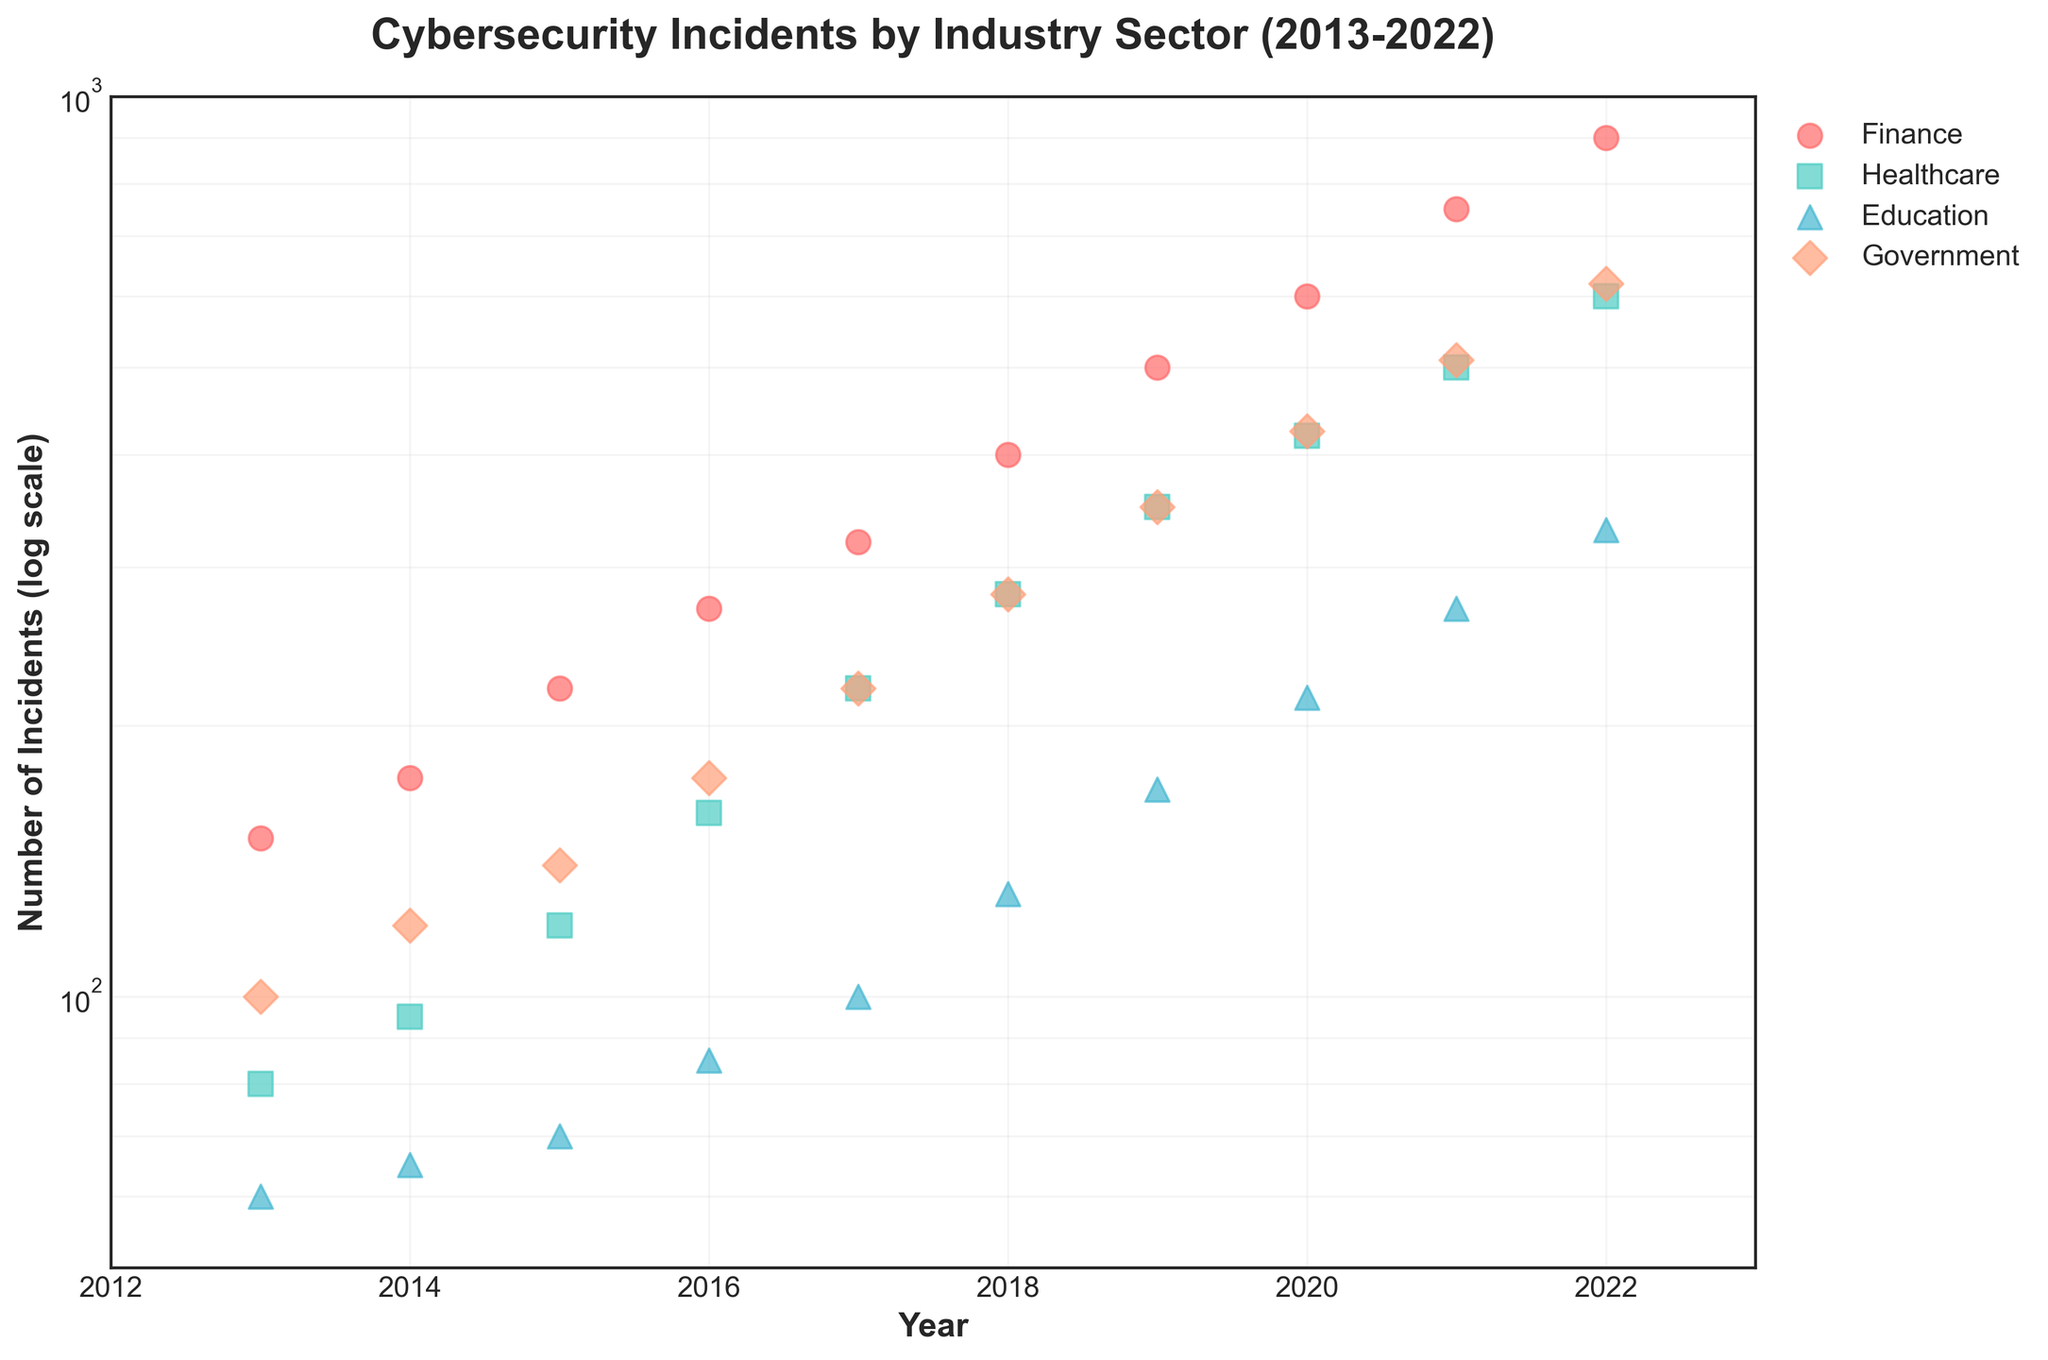Which industry had the highest number of cybersecurity incidents in 2022? By looking at the scatter plot, in 2022, the finance sector had the highest point on the log scale axis indicating the number of incidents.
Answer: Finance What is the trend for the number of cybersecurity incidents in the healthcare industry over the decade? Observing the scatter points for healthcare from 2013 to 2022, there is a consistent upward trend in the number of incidents each year.
Answer: Increasing In 2016, which two industries had almost the same number of cybersecurity incidents? Looking at the scatter plot for 2016, healthcare and government sectors have points very close to each other on the vertical log scale axis.
Answer: Healthcare and Government Which industry showed the fastest growth in the number of cybersecurity incidents from 2013 to 2022? By comparing the distance between the first and last points of each industry's trend line, finance shows the steepest increase from 150 to 900 incidents.
Answer: Finance What is the difference in the number of incidents between finance and education sectors in 2020? For 2020, finance had 600 incidents and education had 215 incidents. Subtracting these gives a difference of 600 - 215 = 385.
Answer: 385 Are there any years where all industries had the number of incidents below 100? By looking at the scatter plot, in 2013, all industries have points below the 100 mark on the vertical log scale.
Answer: Yes, in 2013 Between 2018 and 2019, which industry had the smallest increase in cybersecurity incidents? Observing the change in the vertical distance for each industry, education shows the smallest increase from 130 to 170, which is an increase of 40 incidents.
Answer: Education How many total incidents were there in the government sector between 2013 and 2017? Adding the incidents in the government sector from 2013 to 2017: 100 + 120 + 140 + 175 + 220 = 755.
Answer: 755 Which two industries were closest in the number of incidents in 2021? Looking at the scatter plot for 2021, healthcare and government sectors have points very close to each other on the vertical log scale.
Answer: Healthcare and Government Was the number of incidents in the education sector ever higher than the healthcare sector? By examining the scatter points for each year, the education sector incidents are always lower than healthcare sector incidents.
Answer: No 